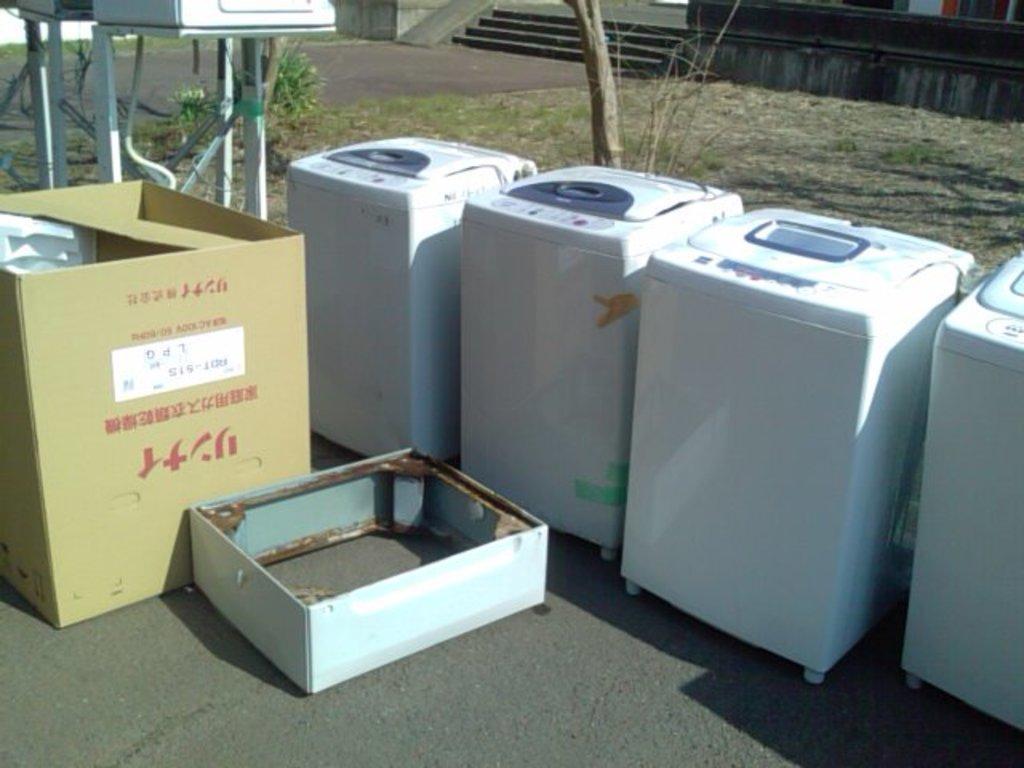Could you give a brief overview of what you see in this image? Here in this picture we can see white colored washing machines present on the road over there and beside that we can see cardboard boxes present and behind that we can see plants and trees present here and there and we can see the ground is covered with grass all over there and on the left side we can see a stand present over there and in the far we can see steps present. 